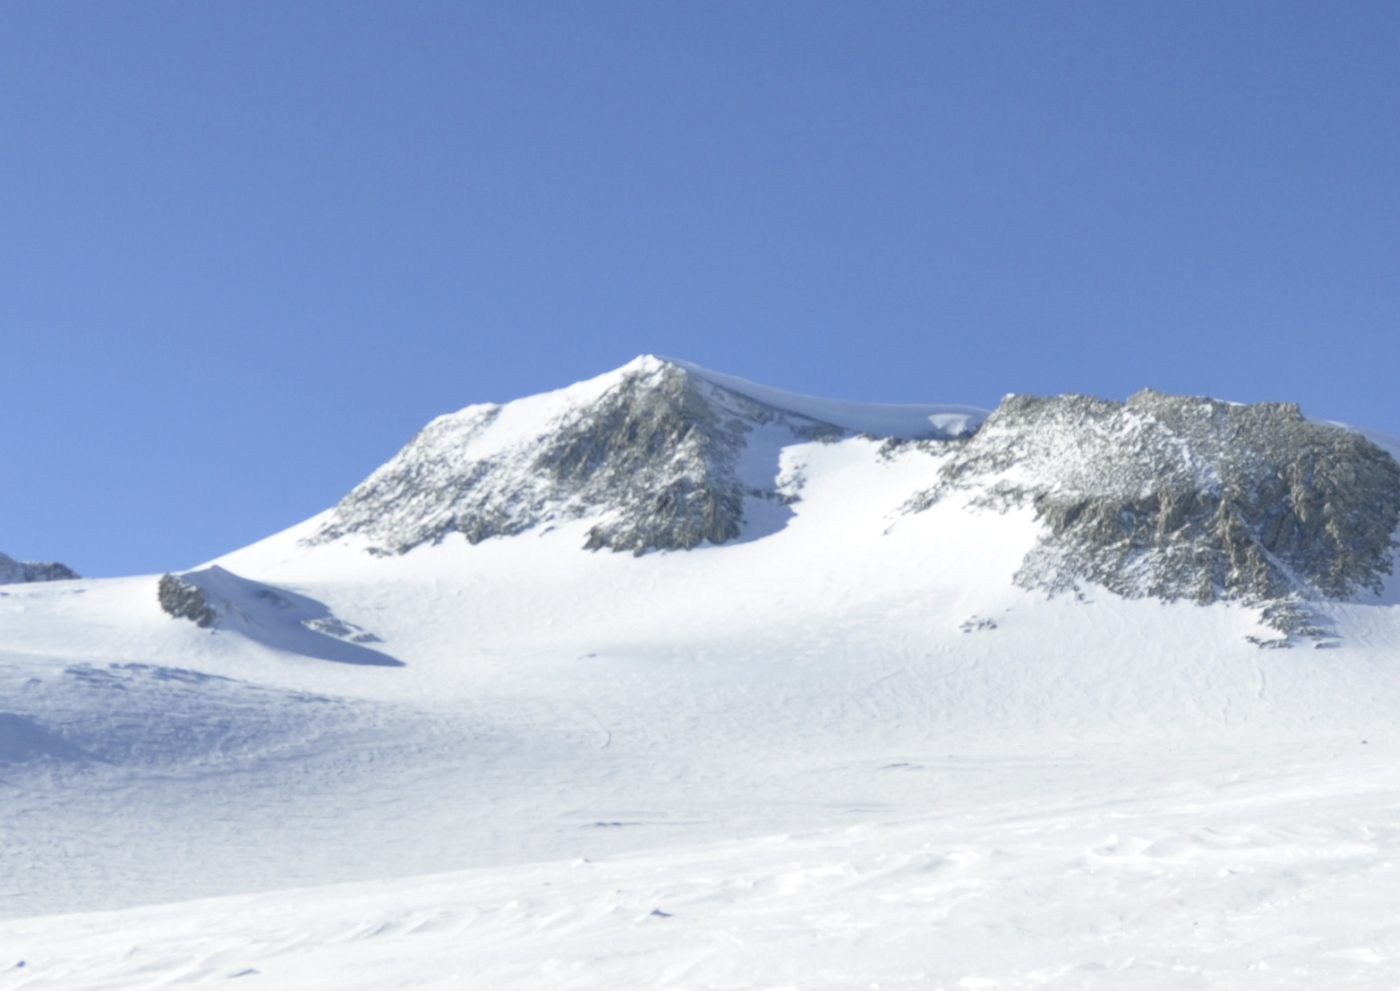If you could fly over Vinson Massif, what would you see from above? If you could take a flight over Vinson Massif, you would witness a breathtaking panorama of Antarctica’s desolate yet stunning landscape. The massif would appear as a commanding presence with its snow-covered peaks sharply contrasting against the clear blue sky. Surrounding the peak, you’d see expansive fields of ice and snow, with occasional rocky outcrops breaking the white monotony. The vast ice sheets would spread out in all directions, giving a sense of the immense scale and isolation of this part of the world. Here, the beauty lies in the untouched simplicity and the sheer enormity of the icy wilderness. Imagine there's a hidden treasure buried somewhere on Vinson Massif. What sort of treasure might it be, and who would have hidden it there? In a whimsical twist of imagination, suppose a hidden treasure lies beneath the icy expanse of Vinson Massif. This treasure might be an ancient chest filled with gold coins, rare gems, and precious artifacts, perhaps left by an elusive explorer centuries ago. Legend has it that this explorer, seeking the ultimate isolation to hide his wealth, chose the remote and inhospitable Vinson Massif. Over time, the exact location of the treasure was forgotten, buried under layers of snow and ice, awaiting discovery by an intrepid adventurer who dared to brave the peak’s harsh conditions in search of unimaginable riches beneath the frozen expanse. 